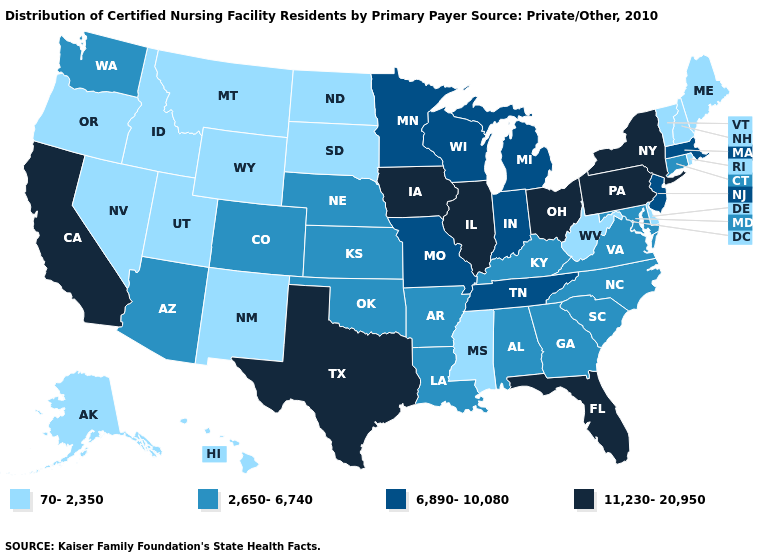Name the states that have a value in the range 6,890-10,080?
Answer briefly. Indiana, Massachusetts, Michigan, Minnesota, Missouri, New Jersey, Tennessee, Wisconsin. Name the states that have a value in the range 6,890-10,080?
Short answer required. Indiana, Massachusetts, Michigan, Minnesota, Missouri, New Jersey, Tennessee, Wisconsin. What is the highest value in the USA?
Give a very brief answer. 11,230-20,950. Is the legend a continuous bar?
Short answer required. No. Among the states that border New Mexico , which have the highest value?
Keep it brief. Texas. Name the states that have a value in the range 6,890-10,080?
Keep it brief. Indiana, Massachusetts, Michigan, Minnesota, Missouri, New Jersey, Tennessee, Wisconsin. Name the states that have a value in the range 6,890-10,080?
Write a very short answer. Indiana, Massachusetts, Michigan, Minnesota, Missouri, New Jersey, Tennessee, Wisconsin. What is the lowest value in the West?
Answer briefly. 70-2,350. Among the states that border Tennessee , does Mississippi have the lowest value?
Quick response, please. Yes. What is the highest value in states that border Illinois?
Keep it brief. 11,230-20,950. What is the lowest value in states that border Idaho?
Write a very short answer. 70-2,350. What is the lowest value in the USA?
Concise answer only. 70-2,350. Which states have the lowest value in the South?
Quick response, please. Delaware, Mississippi, West Virginia. Does Georgia have the lowest value in the South?
Concise answer only. No. What is the lowest value in the USA?
Keep it brief. 70-2,350. 